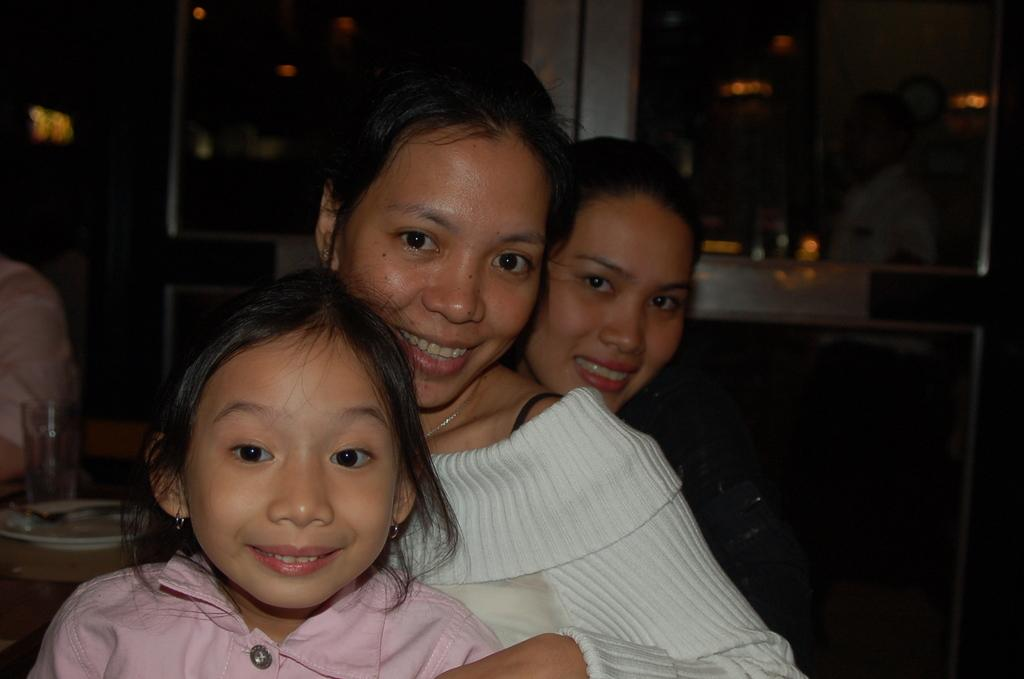What are the women in the image doing? The women in the image are sitting on chairs. What can be seen in the background of the image? In the background of the image, there are cupboards, serving plates, glass tumblers, cutlery, and a table. Is there anyone else present in the image besides the women sitting on chairs? Yes, there is a person standing on the floor in the background of the image. What type of net can be seen in the image? There is no net present in the image. What part of the body is visible on the person standing in the background of the image? The provided facts do not specify which part of the body is visible on the person standing in the background of the image. 